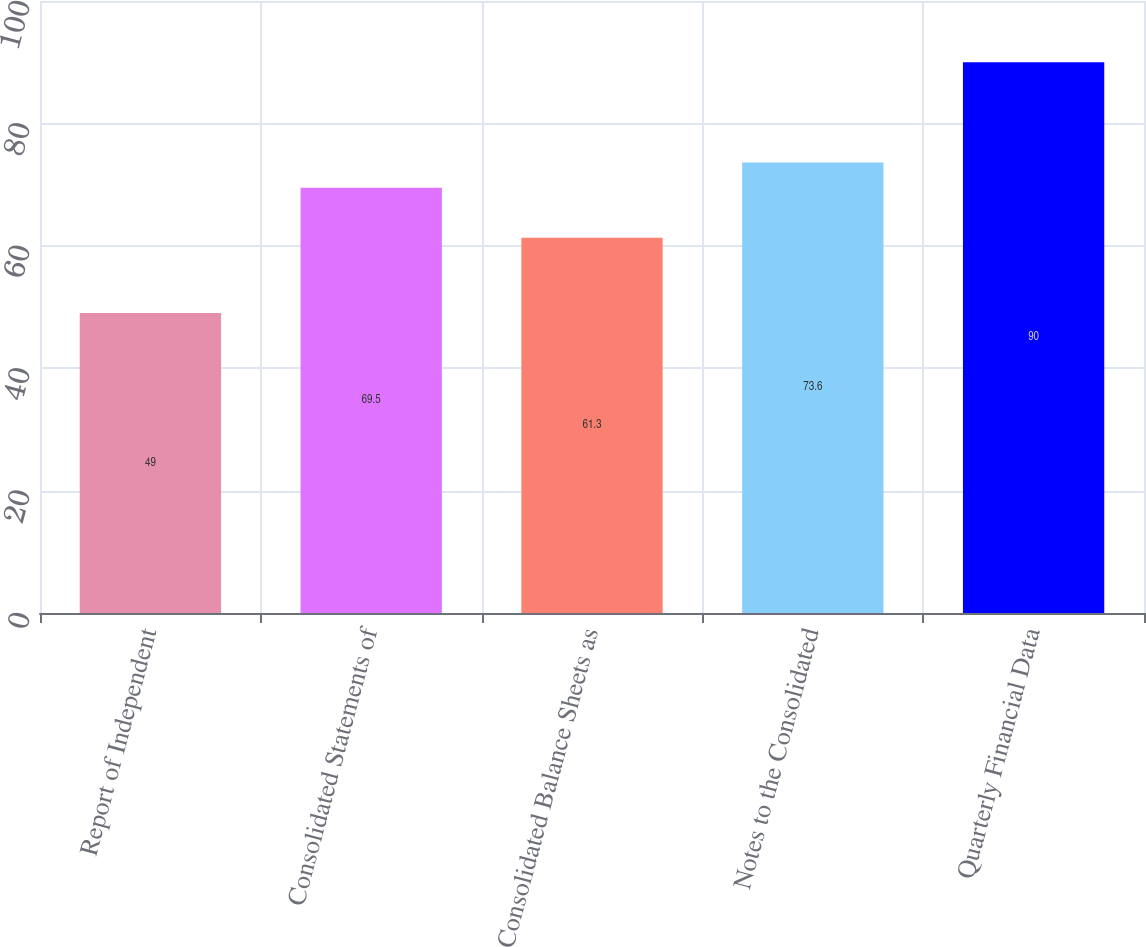<chart> <loc_0><loc_0><loc_500><loc_500><bar_chart><fcel>Report of Independent<fcel>Consolidated Statements of<fcel>Consolidated Balance Sheets as<fcel>Notes to the Consolidated<fcel>Quarterly Financial Data<nl><fcel>49<fcel>69.5<fcel>61.3<fcel>73.6<fcel>90<nl></chart> 